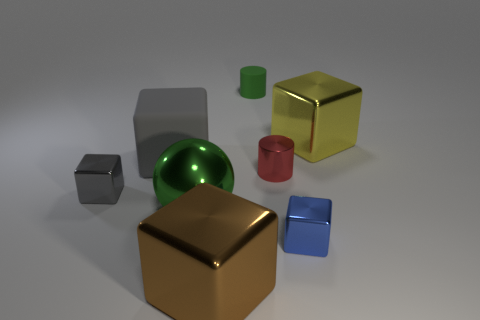What shape is the large green thing that is made of the same material as the red cylinder?
Your response must be concise. Sphere. What is the material of the gray cube that is in front of the gray block that is behind the small red shiny object?
Offer a very short reply. Metal. Do the gray thing that is in front of the red object and the brown thing have the same shape?
Your answer should be very brief. Yes. Are there more shiny blocks that are right of the small gray object than big objects?
Your answer should be very brief. No. There is a small object that is the same color as the large rubber object; what shape is it?
Offer a very short reply. Cube. How many cubes are either gray rubber objects or brown metal objects?
Keep it short and to the point. 2. The big cube in front of the small shiny cube to the left of the green rubber cylinder is what color?
Your answer should be compact. Brown. There is a large matte thing; does it have the same color as the tiny thing that is left of the green rubber object?
Offer a terse response. Yes. What is the size of the brown cube that is the same material as the sphere?
Your answer should be compact. Large. What is the size of the sphere that is the same color as the matte cylinder?
Your answer should be compact. Large. 